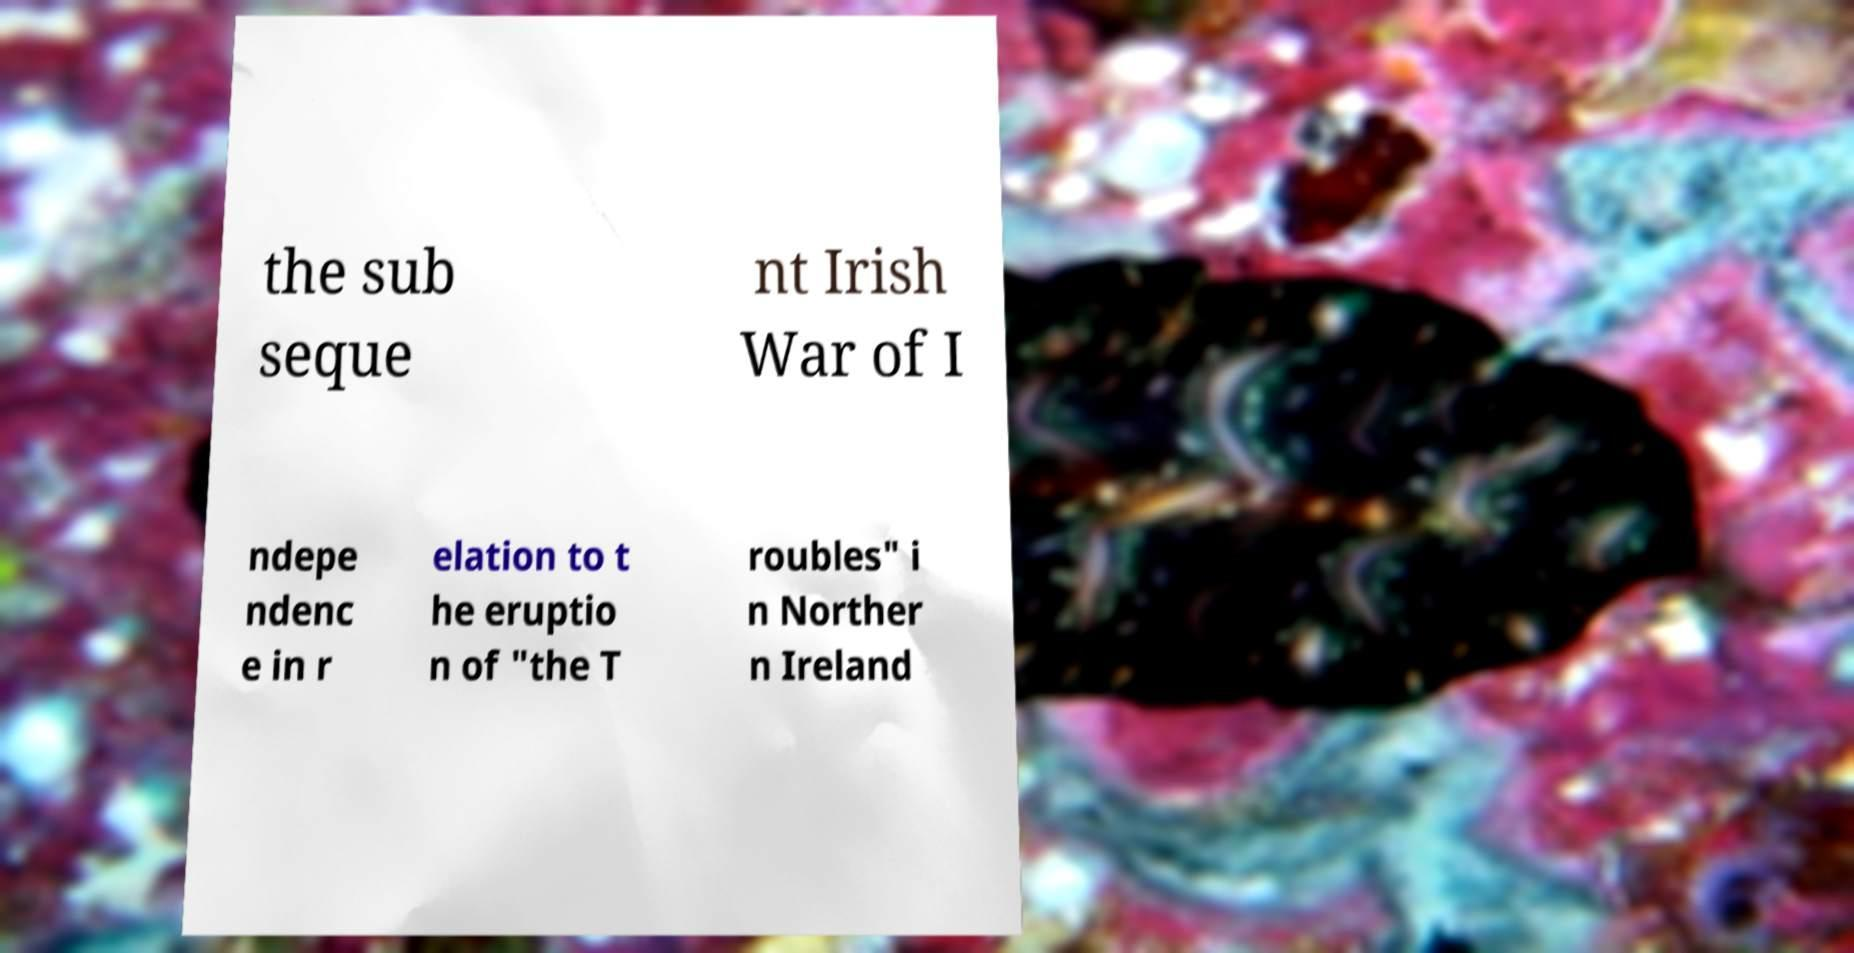Could you extract and type out the text from this image? the sub seque nt Irish War of I ndepe ndenc e in r elation to t he eruptio n of "the T roubles" i n Norther n Ireland 